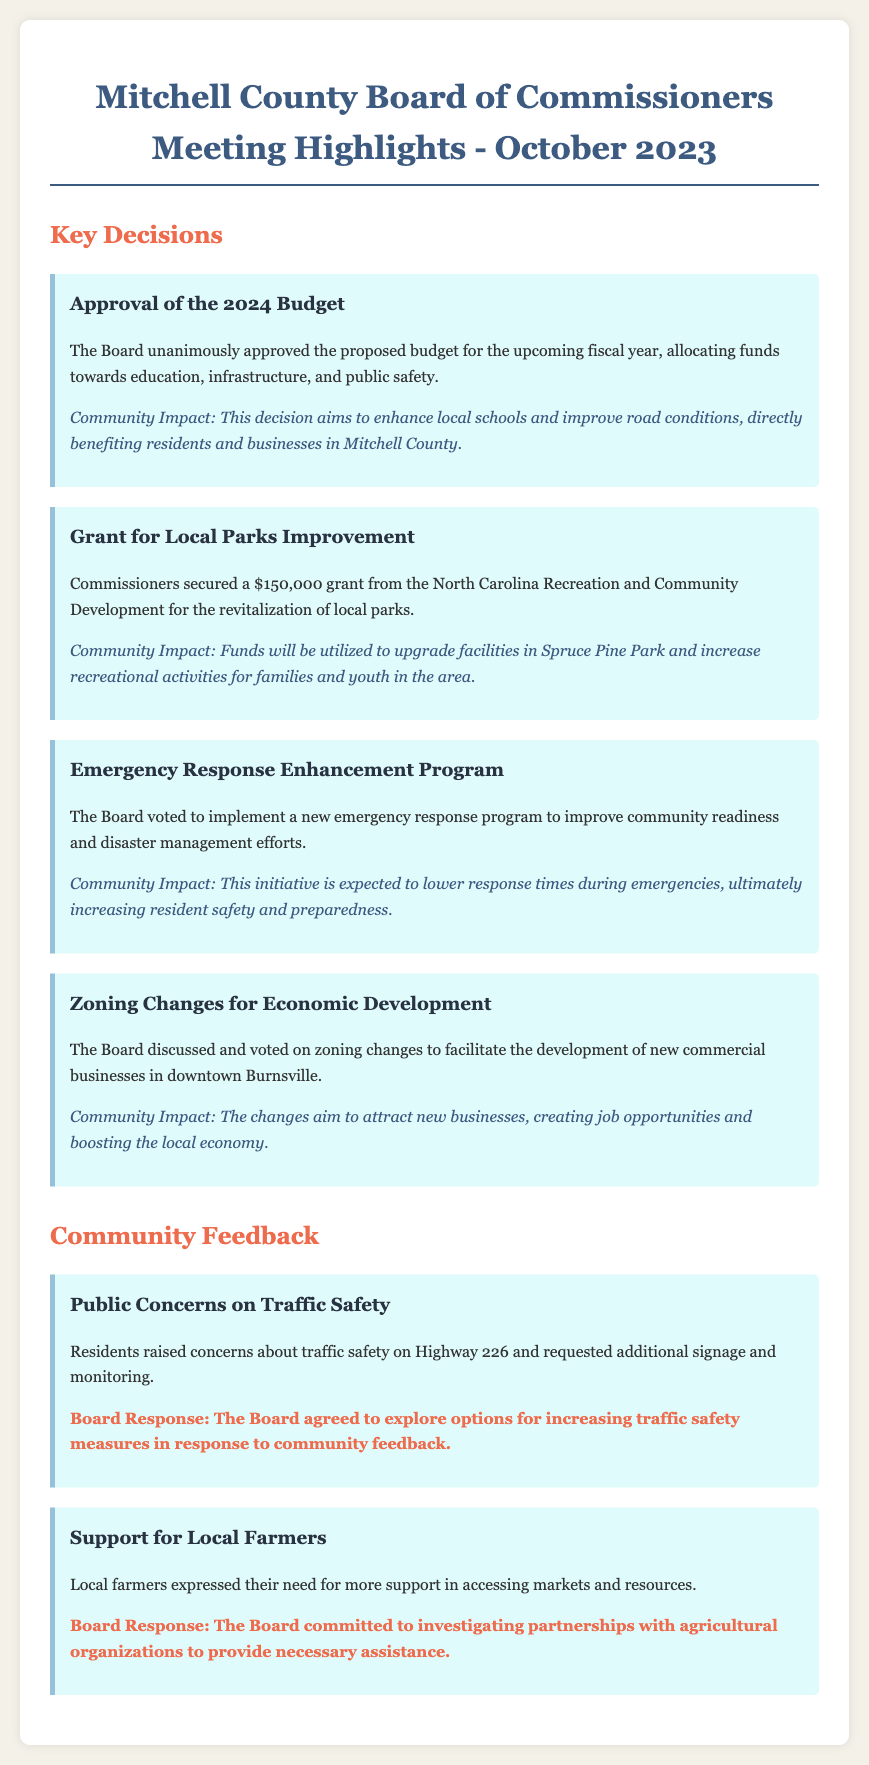What was the total amount of the grant secured for local parks improvement? The grant amount for local parks improvement is stated in the document as $150,000.
Answer: $150,000 What initiative is expected to lower response times during emergencies? The initiative aimed at lowering response times is the Emergency Response Enhancement Program mentioned in the document.
Answer: Emergency Response Enhancement Program Which park is specifically mentioned for upgrades in the grant allocation? The document specifies Spruce Pine Park as the focus for upgrades with the secured grant.
Answer: Spruce Pine Park How many members of the Board approved the 2024 budget? The document indicates that the Board unanimously approved the proposed budget, implying all members agreed.
Answer: Unanimously What community concern did residents raise regarding Highway 226? Residents expressed concerns about traffic safety on Highway 226, as mentioned in the feedback section.
Answer: Traffic Safety Which area is targeted for zoning changes to facilitate commercial business development? The document mentions downtown Burnsville as the targeted area for zoning changes.
Answer: Downtown Burnsville What key area was allocated funds towards in the approved budget? Education, infrastructure, and public safety are the key areas mentioned for funding allocation in the approved budget.
Answer: Education, infrastructure, and public safety What response did the Board give regarding support for local farmers? The Board committed to investigating partnerships with agricultural organizations to support local farmers.
Answer: Investigating partnerships What was a specific feedback topic discussed during the meeting? Public concerns on traffic safety is listed as a specific feedback topic in the meeting minutes.
Answer: Public concerns on traffic safety 